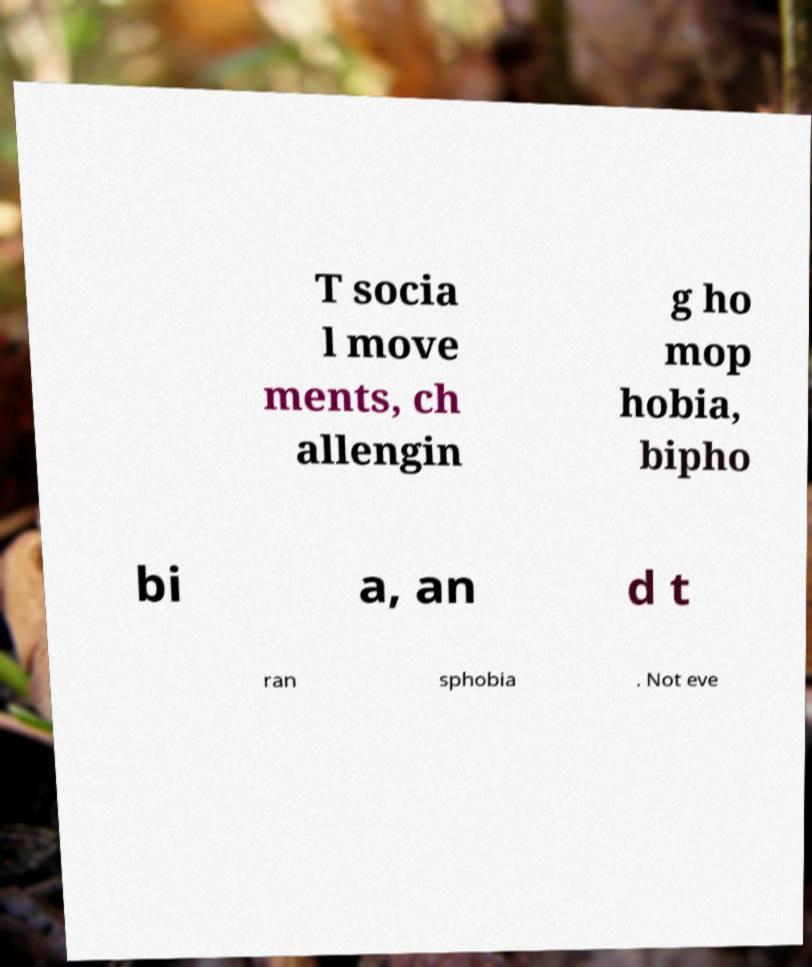What messages or text are displayed in this image? I need them in a readable, typed format. T socia l move ments, ch allengin g ho mop hobia, bipho bi a, an d t ran sphobia . Not eve 